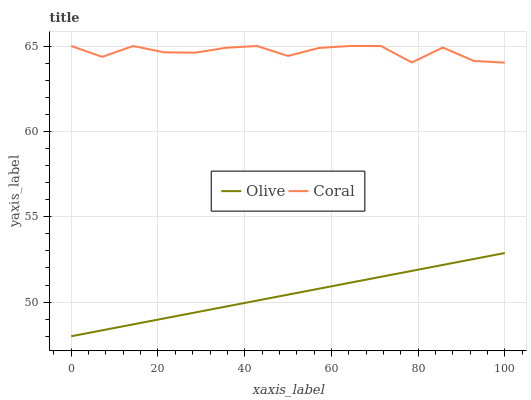Does Olive have the minimum area under the curve?
Answer yes or no. Yes. Does Coral have the maximum area under the curve?
Answer yes or no. Yes. Does Coral have the minimum area under the curve?
Answer yes or no. No. Is Olive the smoothest?
Answer yes or no. Yes. Is Coral the roughest?
Answer yes or no. Yes. Is Coral the smoothest?
Answer yes or no. No. Does Olive have the lowest value?
Answer yes or no. Yes. Does Coral have the lowest value?
Answer yes or no. No. Does Coral have the highest value?
Answer yes or no. Yes. Is Olive less than Coral?
Answer yes or no. Yes. Is Coral greater than Olive?
Answer yes or no. Yes. Does Olive intersect Coral?
Answer yes or no. No. 